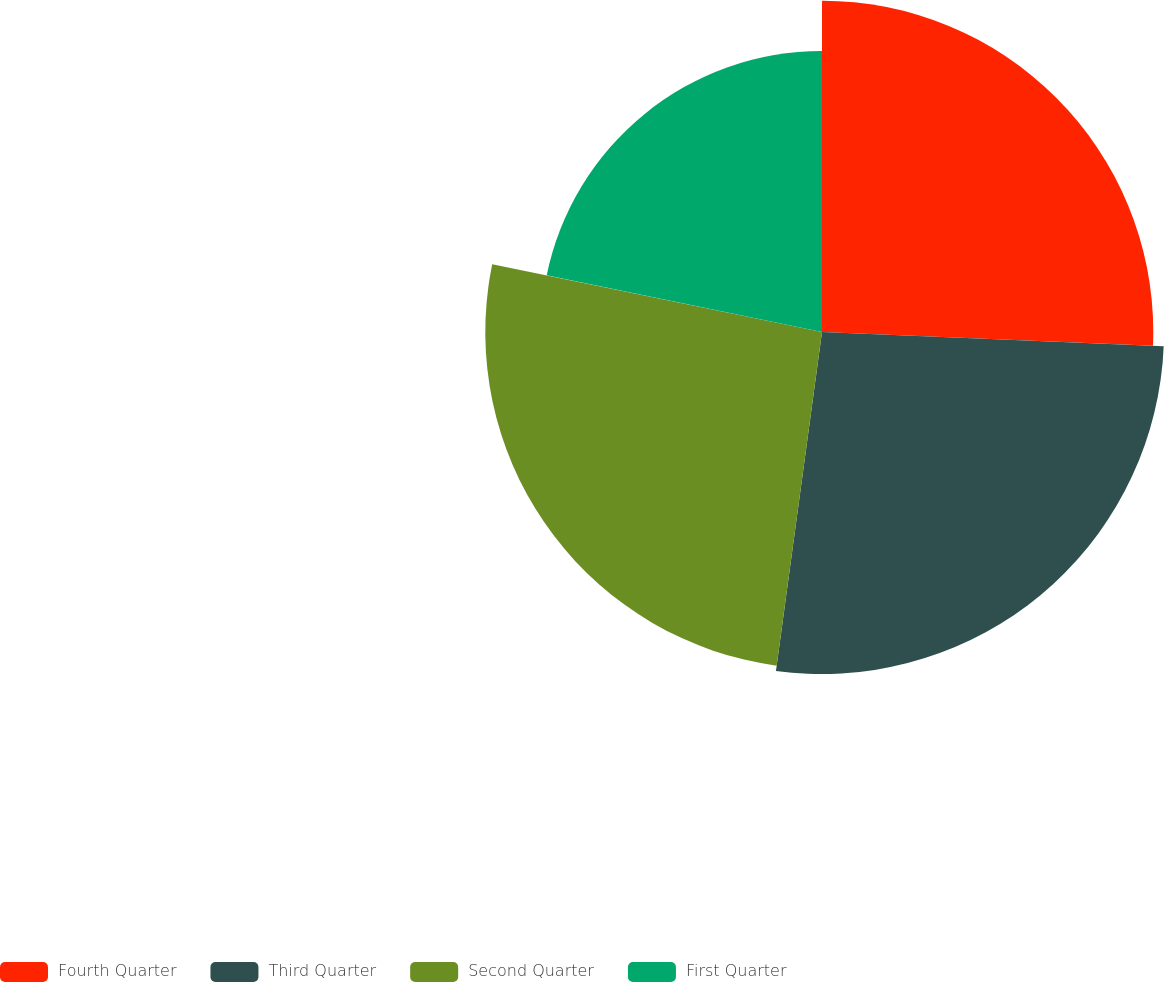Convert chart. <chart><loc_0><loc_0><loc_500><loc_500><pie_chart><fcel>Fourth Quarter<fcel>Third Quarter<fcel>Second Quarter<fcel>First Quarter<nl><fcel>25.66%<fcel>26.49%<fcel>26.08%<fcel>21.77%<nl></chart> 